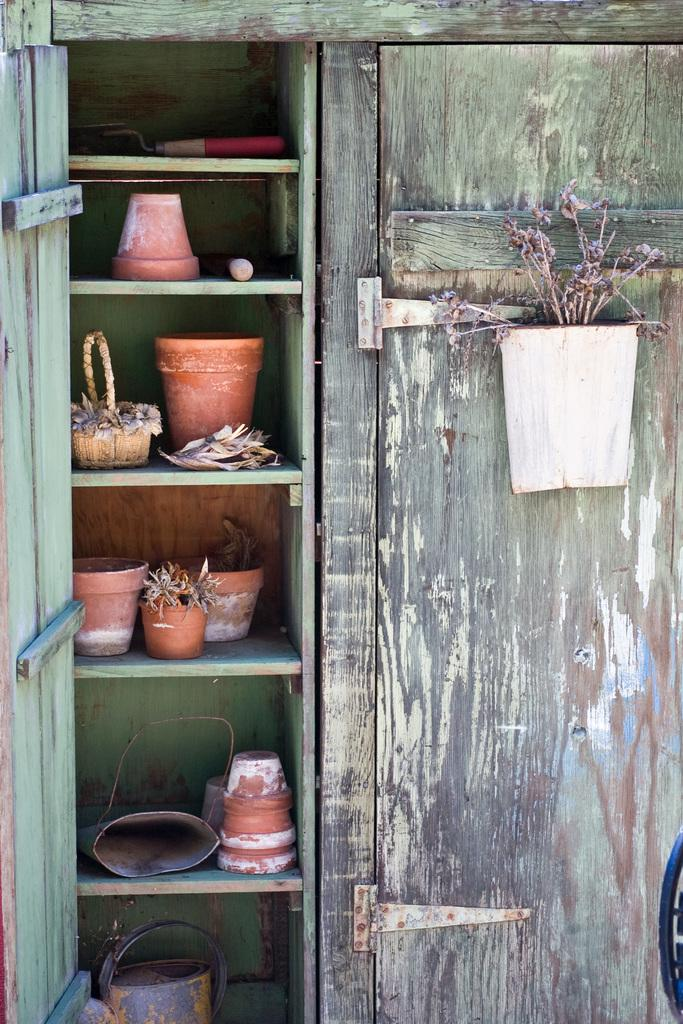What type of furniture is in the image? There is a wooden cupboard in the image. What is hanging on the cupboard door? There is a dry plant in a pot hanging on the cupboard door. What can be seen inside the cupboard? There are pots visible inside the cupboard. What is the health status of the rock in the image? There is no rock present in the image, so it is not possible to determine its health status. 